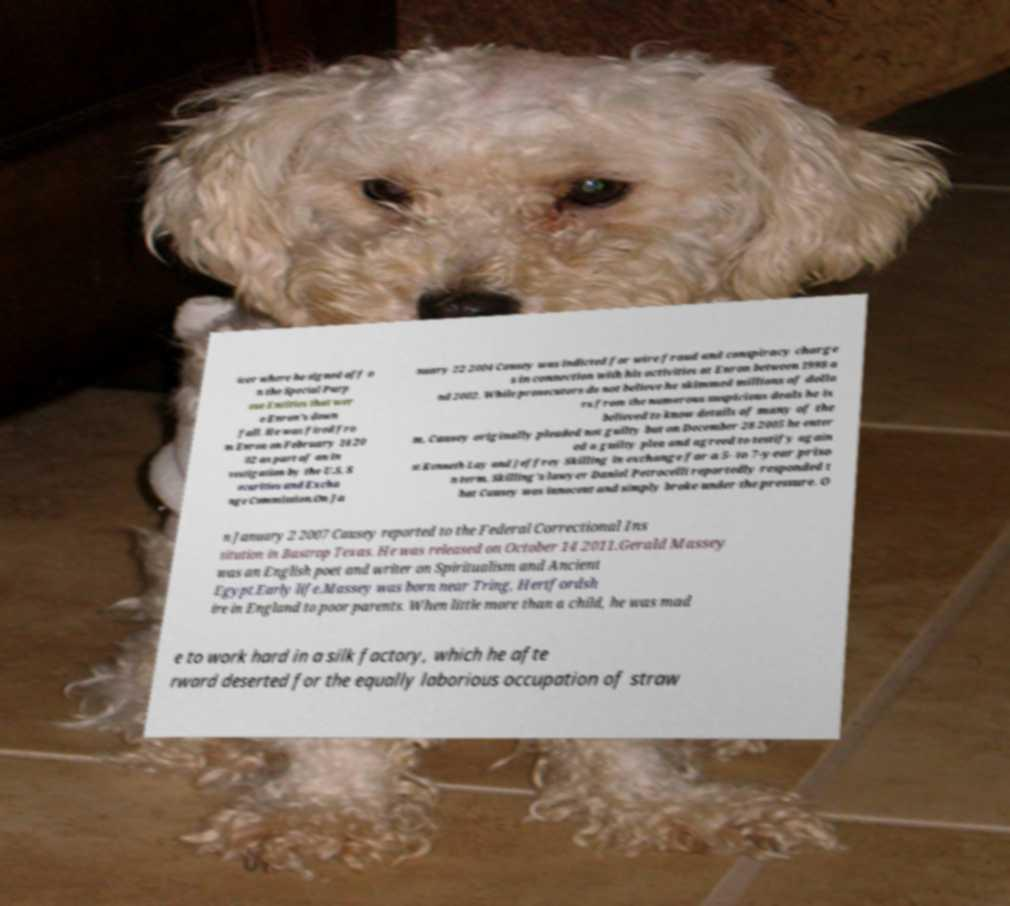I need the written content from this picture converted into text. Can you do that? icer where he signed off o n the Special Purp ose Entities that wer e Enron's down fall. He was fired fro m Enron on February 14 20 02 as part of an in vestigation by the U.S. S ecurities and Excha nge Commission.On Ja nuary 22 2004 Causey was indicted for wire fraud and conspiracy charge s in connection with his activities at Enron between 1998 a nd 2002. While prosecutors do not believe he skimmed millions of dolla rs from the numerous suspicious deals he is believed to know details of many of the m. Causey originally pleaded not guilty but on December 28 2005 he enter ed a guilty plea and agreed to testify again st Kenneth Lay and Jeffrey Skilling in exchange for a 5- to 7-year priso n term. Skilling's lawyer Daniel Petrocelli reportedly responded t hat Causey was innocent and simply broke under the pressure. O n January 2 2007 Causey reported to the Federal Correctional Ins titution in Bastrop Texas. He was released on October 14 2011.Gerald Massey was an English poet and writer on Spiritualism and Ancient Egypt.Early life.Massey was born near Tring, Hertfordsh ire in England to poor parents. When little more than a child, he was mad e to work hard in a silk factory, which he afte rward deserted for the equally laborious occupation of straw 